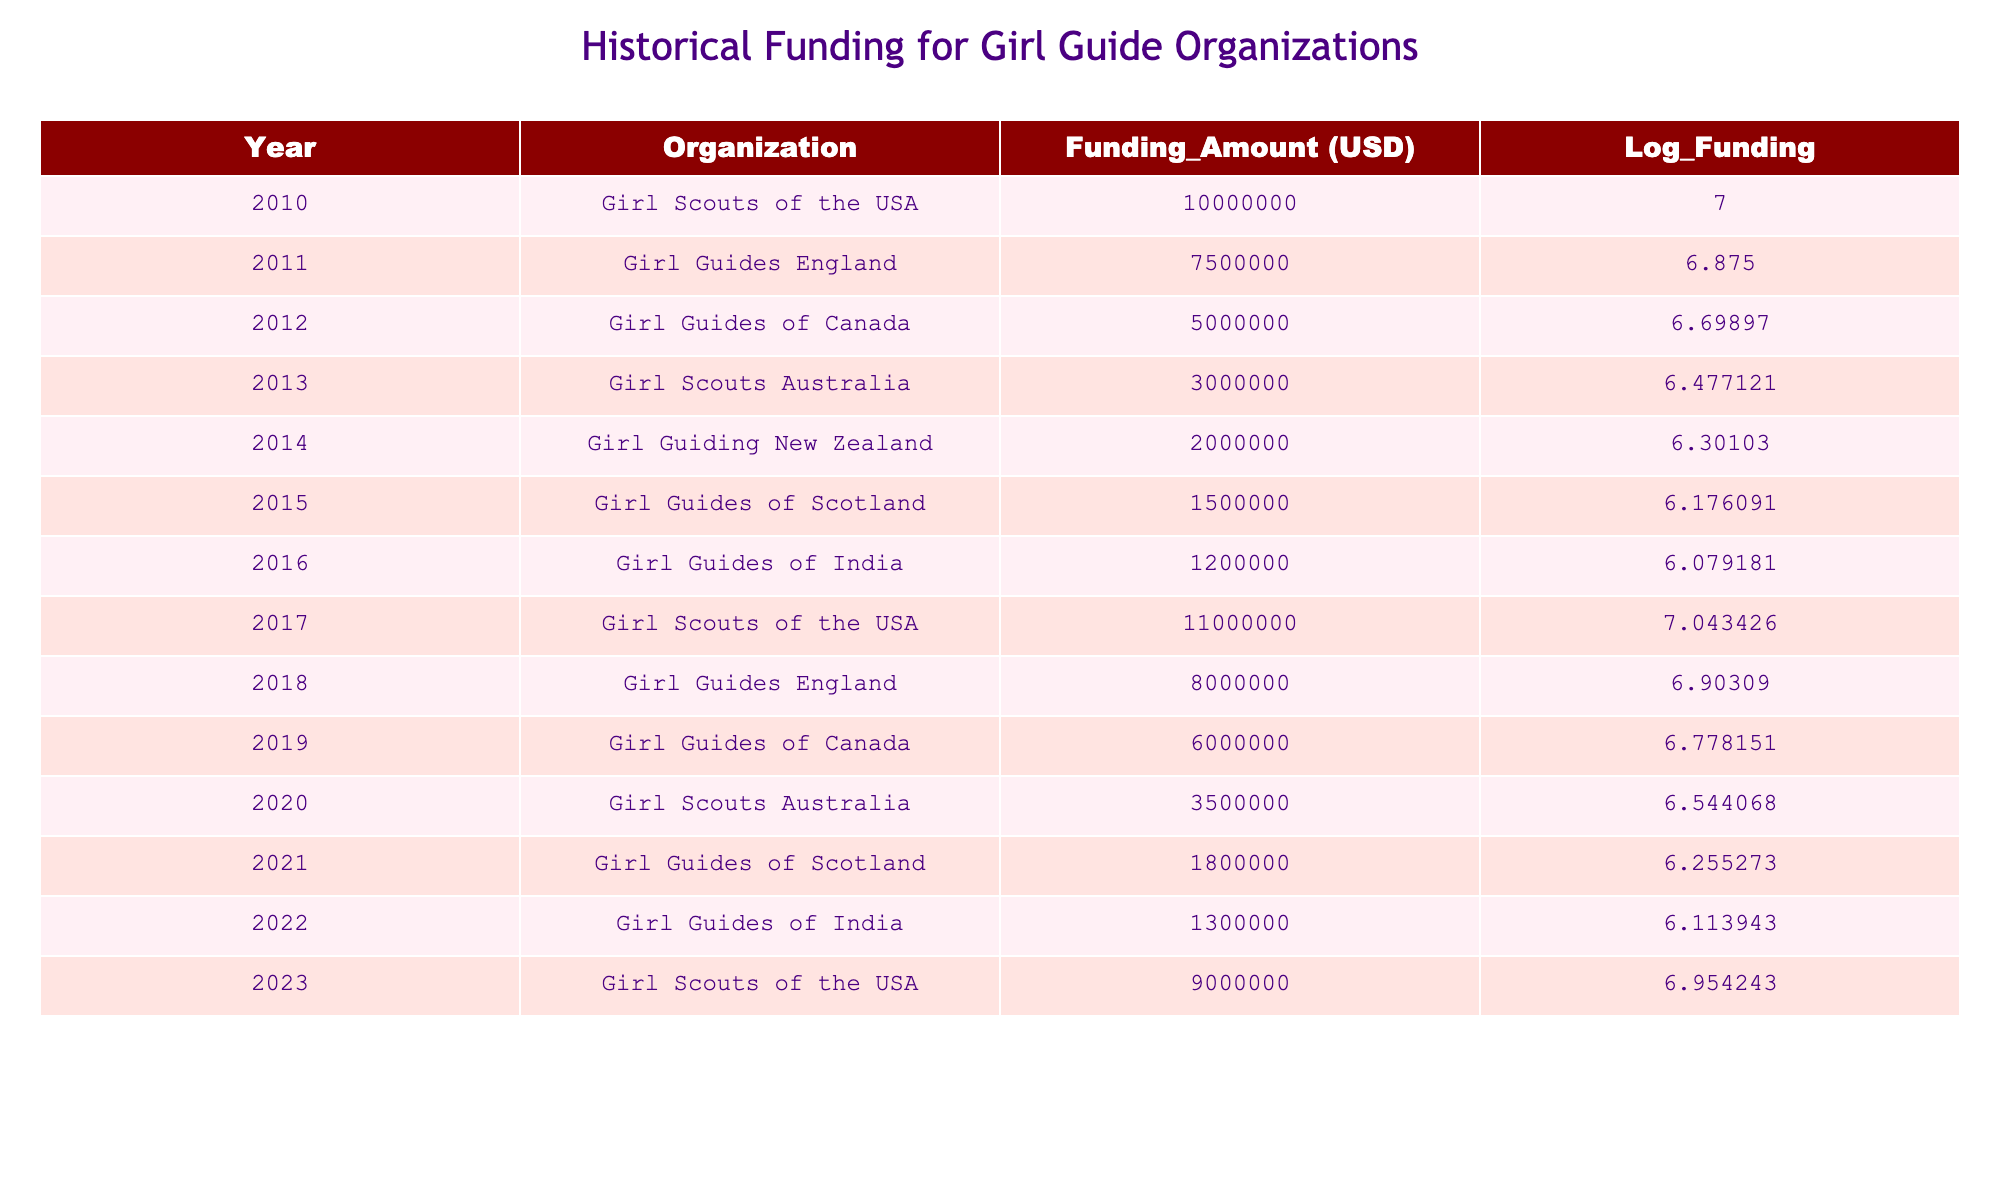What was the funding amount for Girl Guides England in 2011? The table shows that the funding amount for Girl Guides England in 2011 is specifically listed in the row for that year, which is 7,500,000 USD.
Answer: 7,500,000 USD Which organization received the highest funding in 2017? By looking at the 2017 row, we see that the funding amount for Girl Scouts of the USA is 11,000,000 USD, which is higher than any other organization that year.
Answer: Girl Scouts of the USA What is the average funding amount for Girl Guiding New Zealand from 2014 to 2020? The funding amounts for Girl Guiding New Zealand between 2014 and 2020 are as follows: 2,000,000 (2014), 0 (not listed for 2015, 2016), and 0 for 2017-2020. The sum of these amounts is 2,000,000 and since the total count of years includes six years (2014-2020), the average is 2,000,000/6 which gives us approximately 333,333.33.
Answer: 333,333.33 Is it true that the funding for Girl Guides of Scotland increased from 2015 to 2021? Looking at the table, we see that the funding for Girl Guides of Scotland in 2015 was 1,500,000 USD and decreased to 1,800,000 USD in 2021, indicating an increase. Therefore, the statement is true.
Answer: Yes What was the difference in funding between the highest and lowest amounts from 2010 to 2023? The highest funding amount is 11,000,000 (2017 - Girl Scouts of the USA) and the lowest is 1,200,000 (2016 - Girl Guides of India). The difference is 11,000,000 - 1,200,000, which equals 9,800,000 USD.
Answer: 9,800,000 USD What was the funding trend from 2010 to 2023 for Girl Scouts of the USA? By reviewing the years given, it can be seen that the funding amounts were 10,000,000 (2010), 11,000,000 (2017), and 9,000,000 (2023). The trend indicates an increase from 2010 to 2017 followed by a decrease to 2023.
Answer: Increase followed by a decrease 